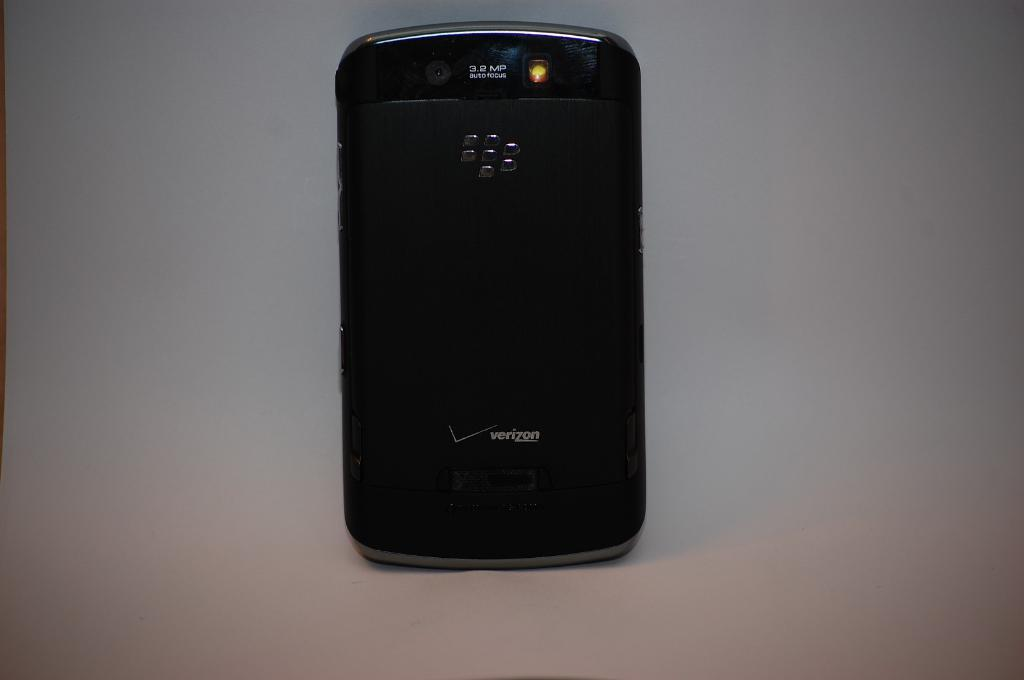<image>
Give a short and clear explanation of the subsequent image. The back of a black cell phone displays the Verizon name and logo. 